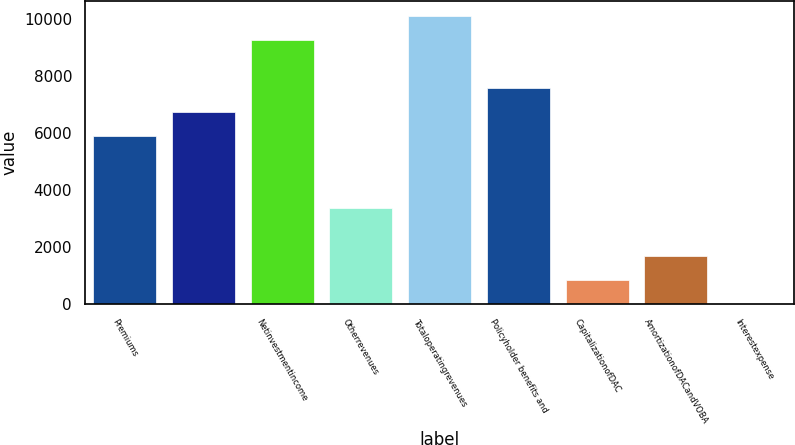<chart> <loc_0><loc_0><loc_500><loc_500><bar_chart><fcel>Premiums<fcel>Unnamed: 1<fcel>Netinvestmentincome<fcel>Otherrevenues<fcel>Totaloperatingrevenues<fcel>Policyholder benefits and<fcel>CapitalizationofDAC<fcel>AmortizationofDACandVOBA<fcel>Interestexpense<nl><fcel>5899.3<fcel>6741.2<fcel>9266.9<fcel>3373.6<fcel>10108.8<fcel>7583.1<fcel>847.9<fcel>1689.8<fcel>6<nl></chart> 